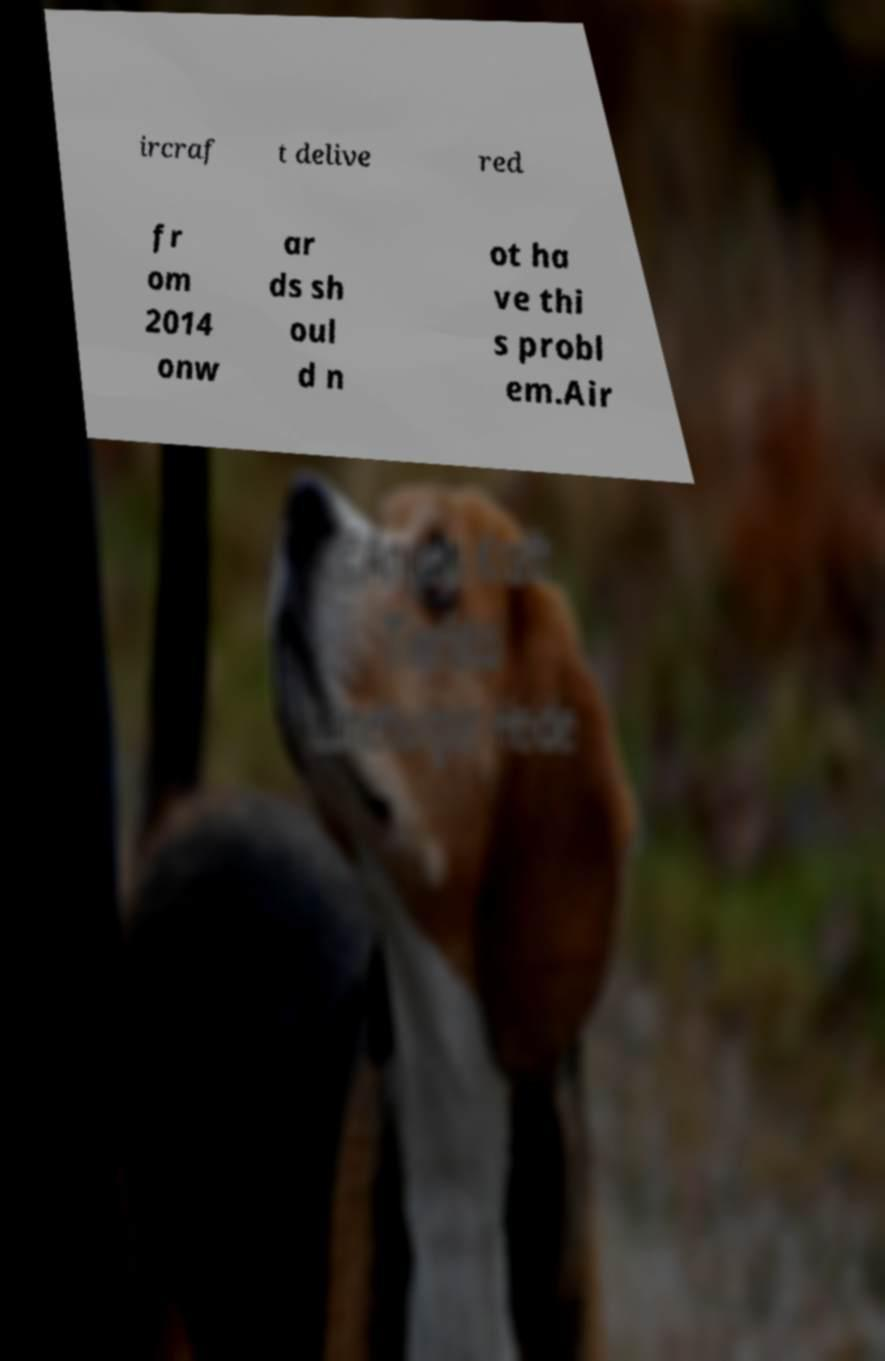There's text embedded in this image that I need extracted. Can you transcribe it verbatim? ircraf t delive red fr om 2014 onw ar ds sh oul d n ot ha ve thi s probl em.Air 